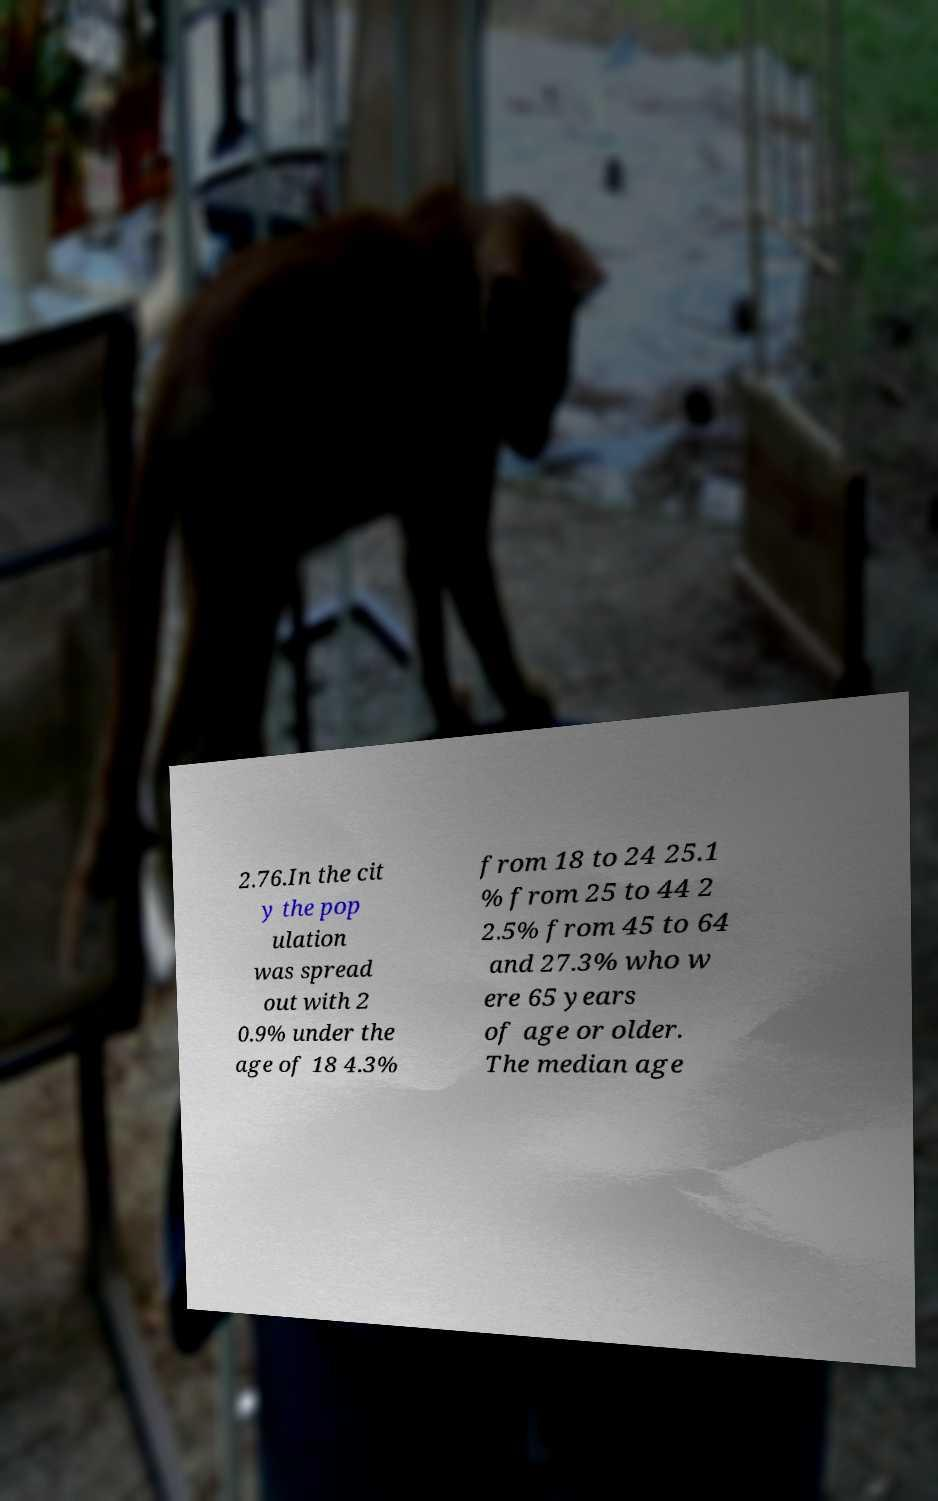What messages or text are displayed in this image? I need them in a readable, typed format. 2.76.In the cit y the pop ulation was spread out with 2 0.9% under the age of 18 4.3% from 18 to 24 25.1 % from 25 to 44 2 2.5% from 45 to 64 and 27.3% who w ere 65 years of age or older. The median age 